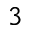<formula> <loc_0><loc_0><loc_500><loc_500>^ { 3 }</formula> 